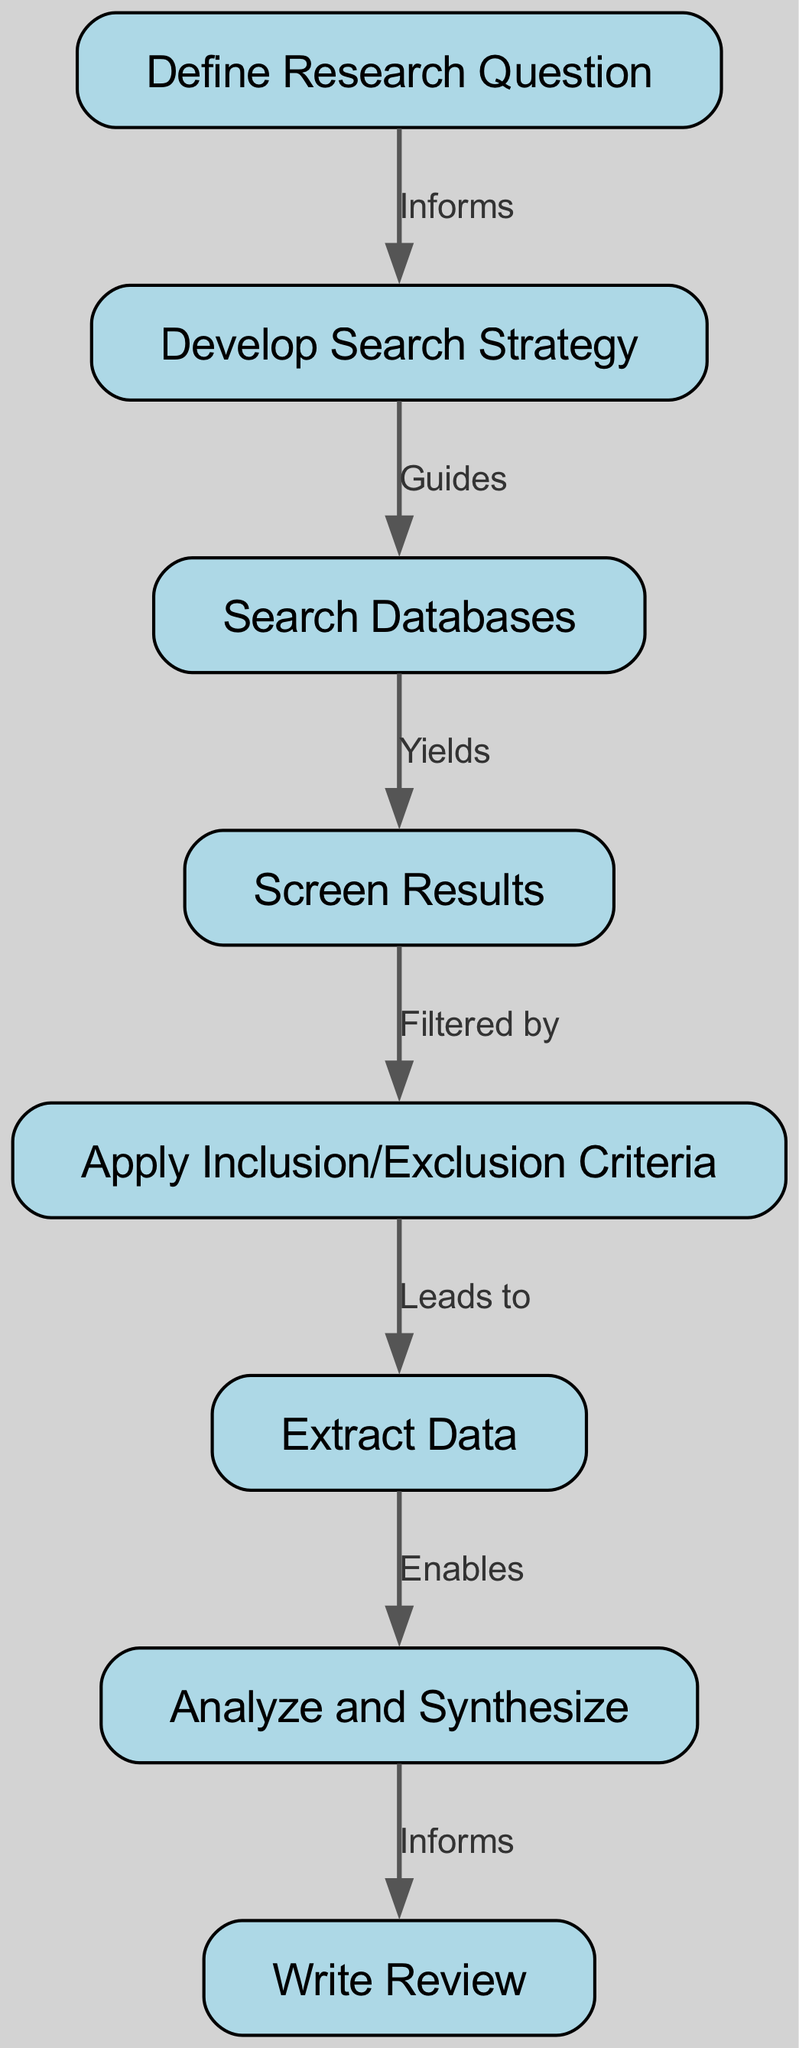What is the first step in the process? The first step is represented by node "1", which is labeled "Define Research Question". This is the starting point of the flowchart as it is at the top of the diagram.
Answer: Define Research Question How many nodes are there in total? By counting all the listed nodes in the provided data, there are 8 distinct steps in the systematic literature review process.
Answer: 8 What label is associated with the edge from "4" to "5"? The edge connecting node "4" (Screen Results) to node "5" (Apply Inclusion/Exclusion Criteria) is labeled "Filtered by". This can be deduced directly from the edge data provided in the diagram.
Answer: Filtered by Which node comes after "Extract Data"? Following node "6" (Extract Data), the next step in the flowchart is node "7", which is titled "Analyze and Synthesize". This follows the sequential order depicted in the edges connecting the nodes.
Answer: Analyze and Synthesize What action leads to applying inclusion/exclusion criteria? The action that leads to applying inclusion/exclusion criteria is "Screen Results" from node "4", as it is the node that directly connects to node "5" allowing for this action.
Answer: Screen Results Which step informs the writing of the review? The step that informs the writing of the review is "Analyze and Synthesize", which is node "7". The edge labeled "Informs" connects this node to node "8", which is "Write Review".
Answer: Analyze and Synthesize What is the relationship between "Develop Search Strategy" and "Search Databases"? The relationship is described by the edge labeled "Guides" that connects node "2" (Develop Search Strategy) to node "3" (Search Databases), indicating that the search strategy guides the database search process.
Answer: Guides How many edges are present in the flowchart? By counting the number of connections between nodes in the provided data, there are 7 edges that illustrate the relationships and transitions between the various steps in the review process.
Answer: 7 